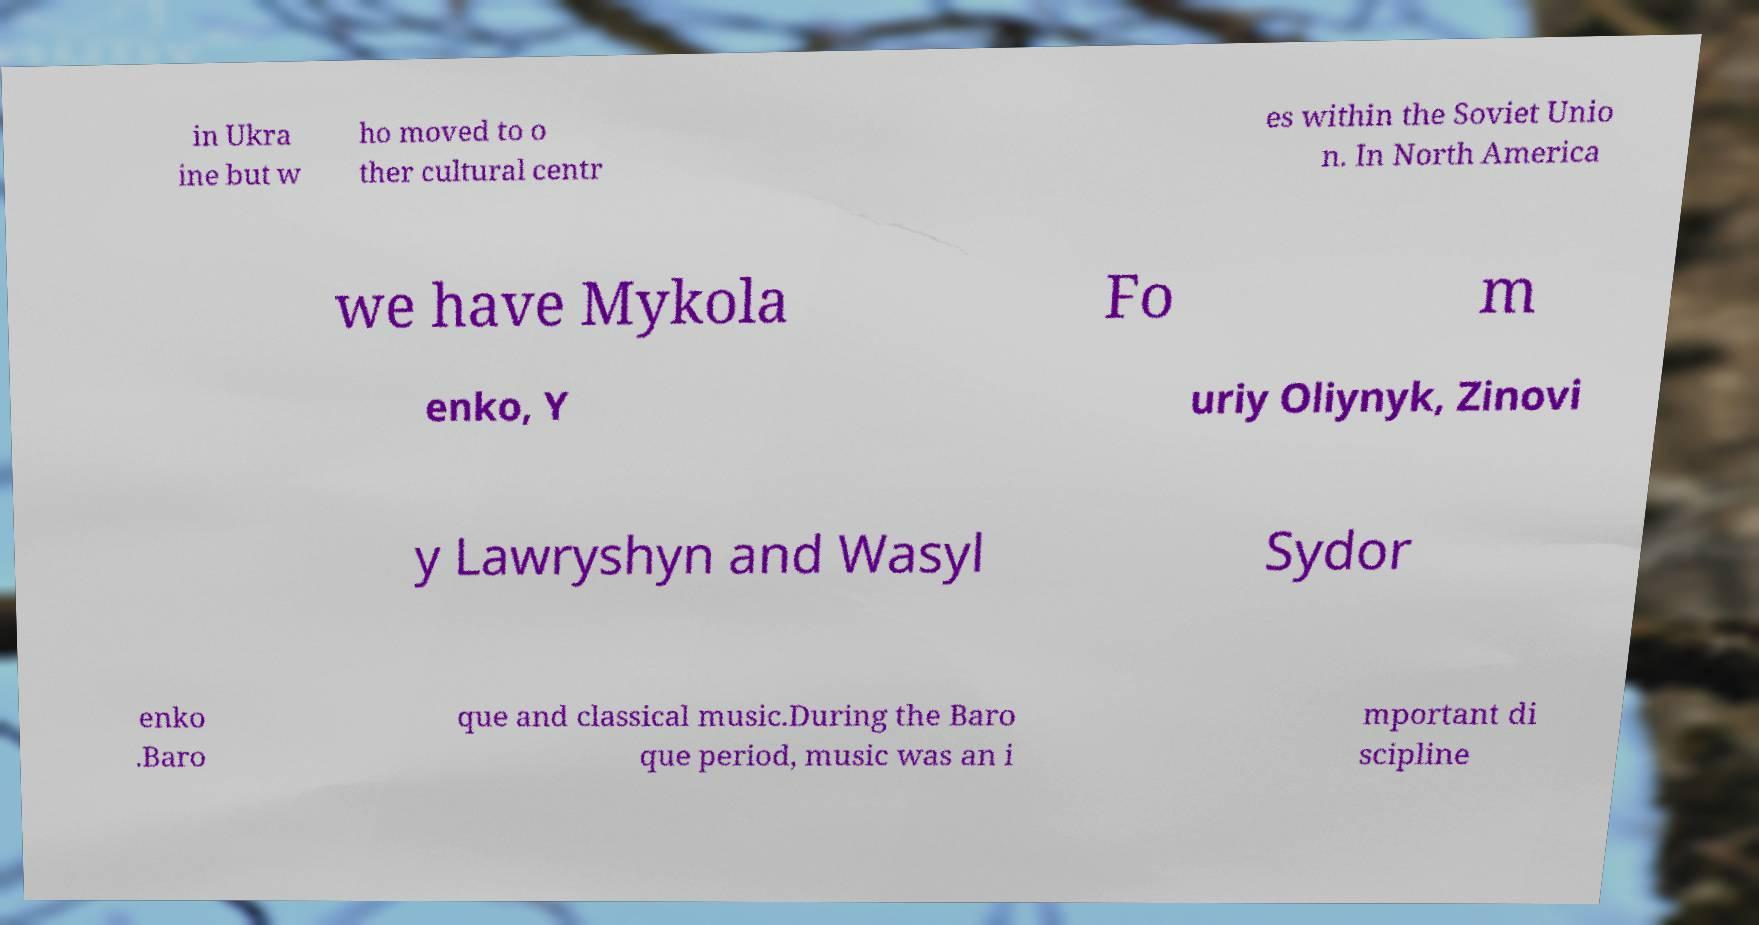What messages or text are displayed in this image? I need them in a readable, typed format. in Ukra ine but w ho moved to o ther cultural centr es within the Soviet Unio n. In North America we have Mykola Fo m enko, Y uriy Oliynyk, Zinovi y Lawryshyn and Wasyl Sydor enko .Baro que and classical music.During the Baro que period, music was an i mportant di scipline 